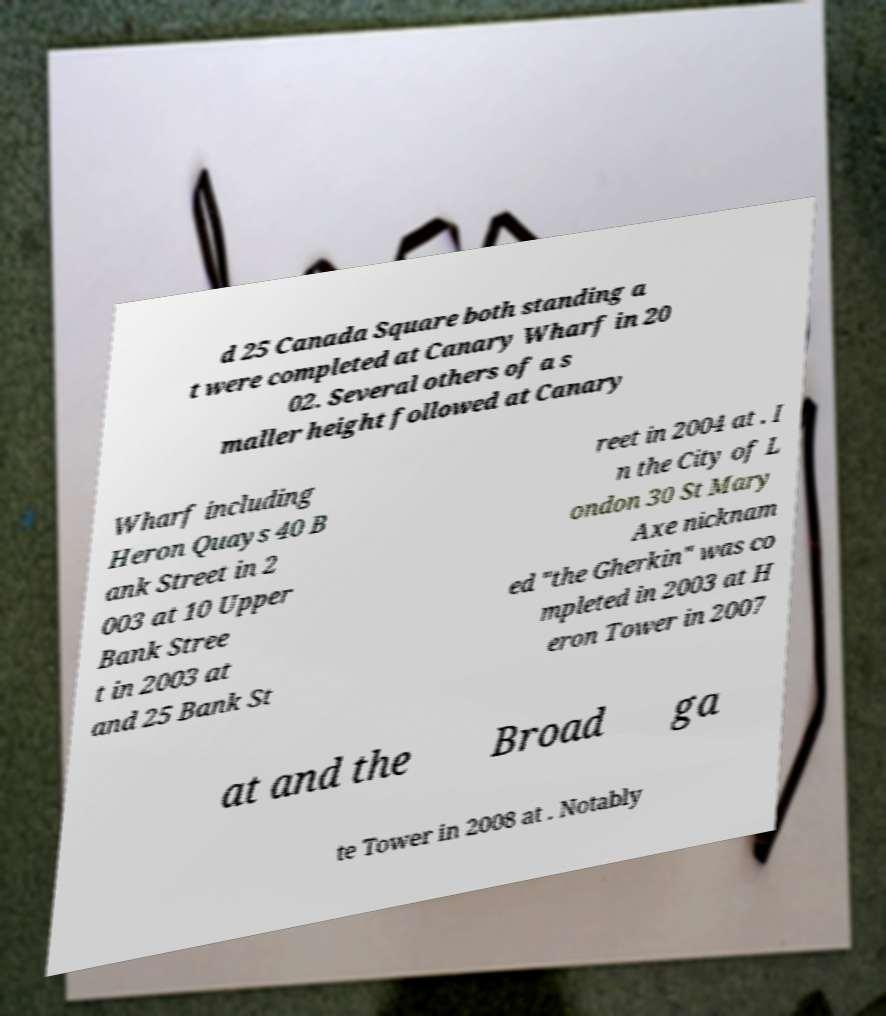Can you read and provide the text displayed in the image?This photo seems to have some interesting text. Can you extract and type it out for me? d 25 Canada Square both standing a t were completed at Canary Wharf in 20 02. Several others of a s maller height followed at Canary Wharf including Heron Quays 40 B ank Street in 2 003 at 10 Upper Bank Stree t in 2003 at and 25 Bank St reet in 2004 at . I n the City of L ondon 30 St Mary Axe nicknam ed "the Gherkin" was co mpleted in 2003 at H eron Tower in 2007 at and the Broad ga te Tower in 2008 at . Notably 